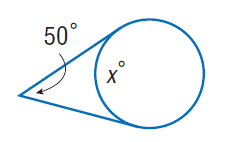Question: Find x. Assume that any segment that appears to be tangent is tangent.
Choices:
A. 50
B. 65
C. 115
D. 130
Answer with the letter. Answer: D 